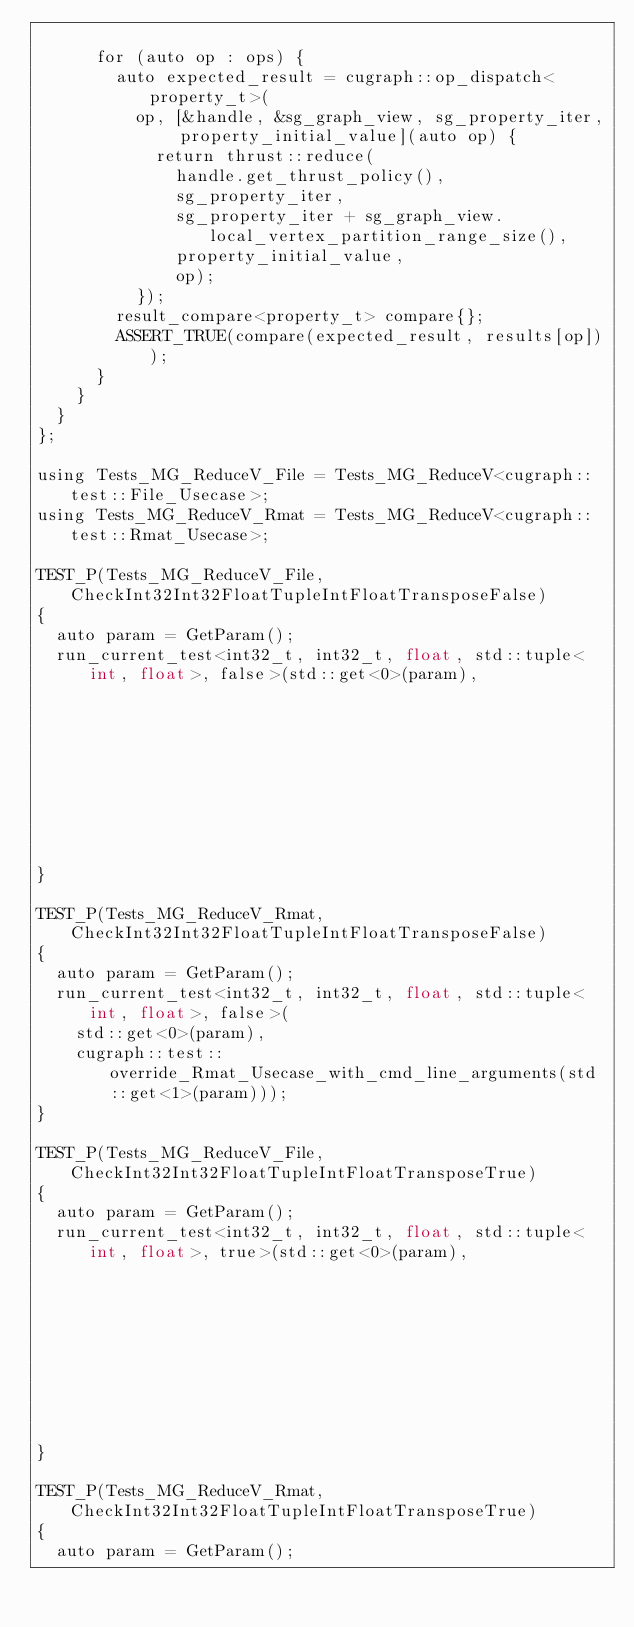Convert code to text. <code><loc_0><loc_0><loc_500><loc_500><_Cuda_>
      for (auto op : ops) {
        auto expected_result = cugraph::op_dispatch<property_t>(
          op, [&handle, &sg_graph_view, sg_property_iter, property_initial_value](auto op) {
            return thrust::reduce(
              handle.get_thrust_policy(),
              sg_property_iter,
              sg_property_iter + sg_graph_view.local_vertex_partition_range_size(),
              property_initial_value,
              op);
          });
        result_compare<property_t> compare{};
        ASSERT_TRUE(compare(expected_result, results[op]));
      }
    }
  }
};

using Tests_MG_ReduceV_File = Tests_MG_ReduceV<cugraph::test::File_Usecase>;
using Tests_MG_ReduceV_Rmat = Tests_MG_ReduceV<cugraph::test::Rmat_Usecase>;

TEST_P(Tests_MG_ReduceV_File, CheckInt32Int32FloatTupleIntFloatTransposeFalse)
{
  auto param = GetParam();
  run_current_test<int32_t, int32_t, float, std::tuple<int, float>, false>(std::get<0>(param),
                                                                           std::get<1>(param));
}

TEST_P(Tests_MG_ReduceV_Rmat, CheckInt32Int32FloatTupleIntFloatTransposeFalse)
{
  auto param = GetParam();
  run_current_test<int32_t, int32_t, float, std::tuple<int, float>, false>(
    std::get<0>(param),
    cugraph::test::override_Rmat_Usecase_with_cmd_line_arguments(std::get<1>(param)));
}

TEST_P(Tests_MG_ReduceV_File, CheckInt32Int32FloatTupleIntFloatTransposeTrue)
{
  auto param = GetParam();
  run_current_test<int32_t, int32_t, float, std::tuple<int, float>, true>(std::get<0>(param),
                                                                          std::get<1>(param));
}

TEST_P(Tests_MG_ReduceV_Rmat, CheckInt32Int32FloatTupleIntFloatTransposeTrue)
{
  auto param = GetParam();</code> 